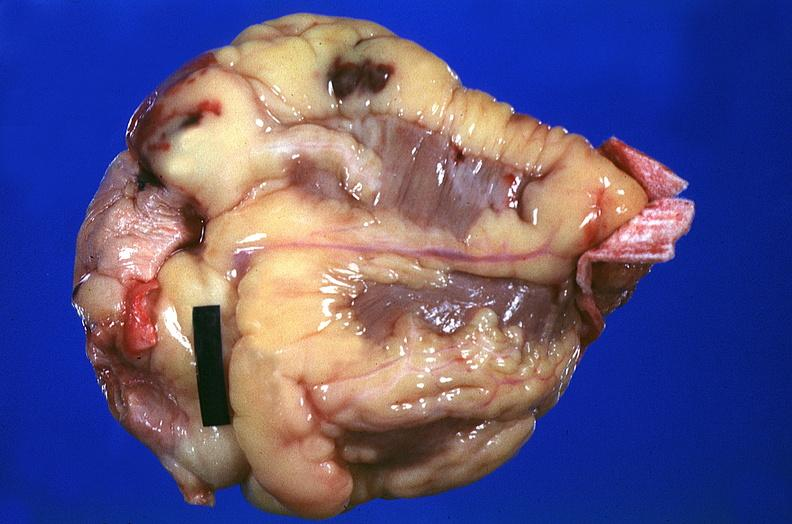s cardiovascular present?
Answer the question using a single word or phrase. Yes 